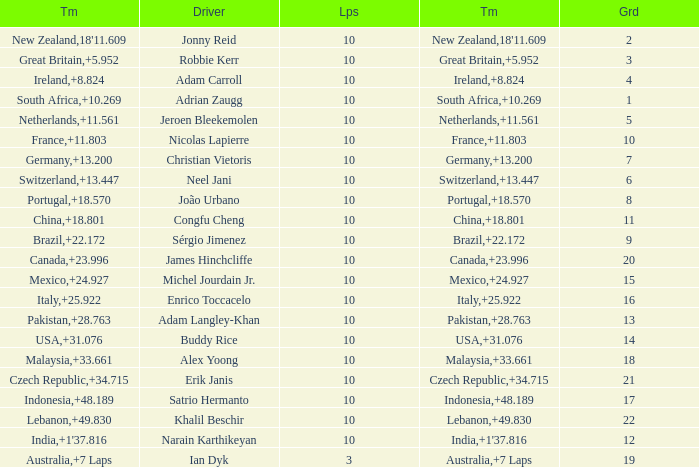What is the Grid number for the Team from Italy? 1.0. 